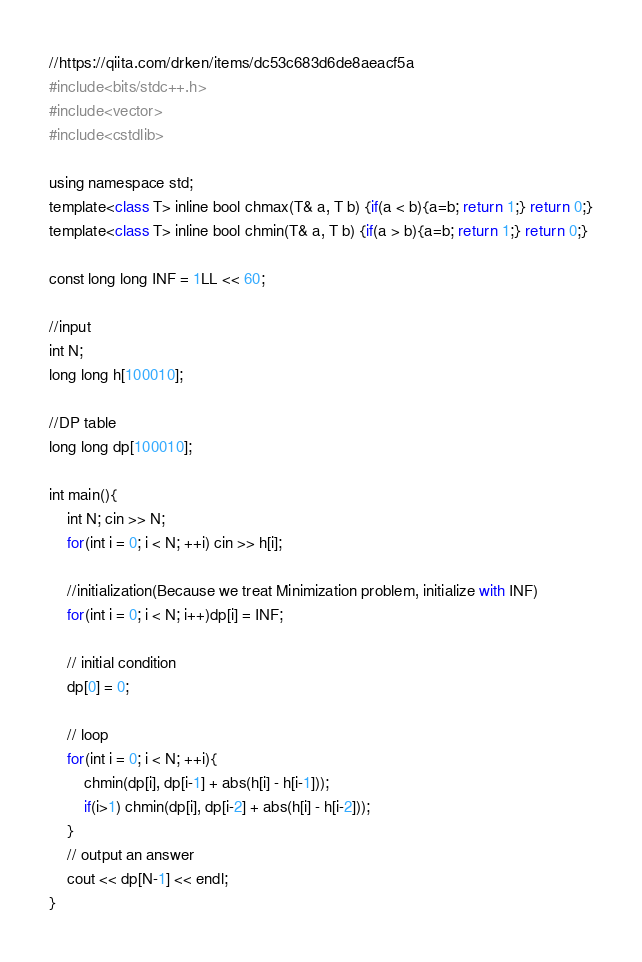<code> <loc_0><loc_0><loc_500><loc_500><_Python_>//https://qiita.com/drken/items/dc53c683d6de8aeacf5a
#include<bits/stdc++.h>
#include<vector>
#include<cstdlib>

using namespace std;
template<class T> inline bool chmax(T& a, T b) {if(a < b){a=b; return 1;} return 0;}
template<class T> inline bool chmin(T& a, T b) {if(a > b){a=b; return 1;} return 0;}

const long long INF = 1LL << 60;

//input
int N;
long long h[100010];

//DP table
long long dp[100010];

int main(){
    int N; cin >> N;
    for(int i = 0; i < N; ++i) cin >> h[i];

    //initialization(Because we treat Minimization problem, initialize with INF)
    for(int i = 0; i < N; i++)dp[i] = INF;
    
    // initial condition
    dp[0] = 0;

    // loop
    for(int i = 0; i < N; ++i){
        chmin(dp[i], dp[i-1] + abs(h[i] - h[i-1]));
        if(i>1) chmin(dp[i], dp[i-2] + abs(h[i] - h[i-2]));
    }
    // output an answer
    cout << dp[N-1] << endl;
}</code> 